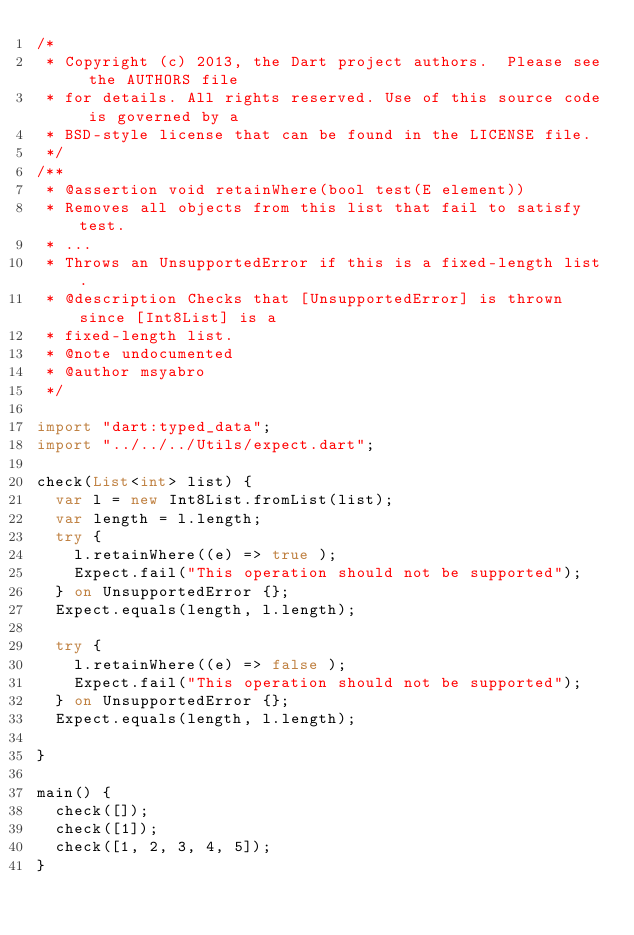Convert code to text. <code><loc_0><loc_0><loc_500><loc_500><_Dart_>/*
 * Copyright (c) 2013, the Dart project authors.  Please see the AUTHORS file
 * for details. All rights reserved. Use of this source code is governed by a
 * BSD-style license that can be found in the LICENSE file.
 */
/**
 * @assertion void retainWhere(bool test(E element))
 * Removes all objects from this list that fail to satisfy test.
 * ...
 * Throws an UnsupportedError if this is a fixed-length list.
 * @description Checks that [UnsupportedError] is thrown since [Int8List] is a
 * fixed-length list.
 * @note undocumented
 * @author msyabro
 */

import "dart:typed_data";
import "../../../Utils/expect.dart";

check(List<int> list) {
  var l = new Int8List.fromList(list);
  var length = l.length;
  try {
    l.retainWhere((e) => true );
    Expect.fail("This operation should not be supported");
  } on UnsupportedError {};
  Expect.equals(length, l.length);

  try {
    l.retainWhere((e) => false );
    Expect.fail("This operation should not be supported");
  } on UnsupportedError {};
  Expect.equals(length, l.length);

}

main() {
  check([]);
  check([1]);
  check([1, 2, 3, 4, 5]);
}
</code> 